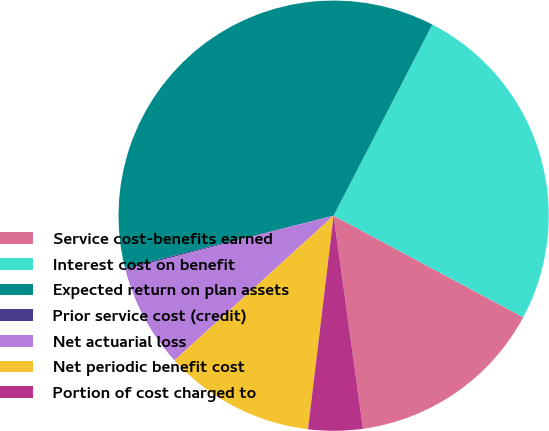Convert chart to OTSL. <chart><loc_0><loc_0><loc_500><loc_500><pie_chart><fcel>Service cost-benefits earned<fcel>Interest cost on benefit<fcel>Expected return on plan assets<fcel>Prior service cost (credit)<fcel>Net actuarial loss<fcel>Net periodic benefit cost<fcel>Portion of cost charged to<nl><fcel>14.99%<fcel>25.24%<fcel>36.49%<fcel>0.12%<fcel>7.72%<fcel>11.35%<fcel>4.08%<nl></chart> 